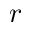<formula> <loc_0><loc_0><loc_500><loc_500>r</formula> 